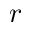<formula> <loc_0><loc_0><loc_500><loc_500>r</formula> 